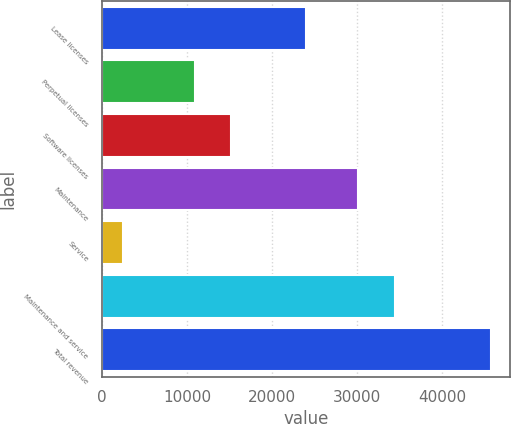<chart> <loc_0><loc_0><loc_500><loc_500><bar_chart><fcel>Lease licenses<fcel>Perpetual licenses<fcel>Software licenses<fcel>Maintenance<fcel>Service<fcel>Maintenance and service<fcel>Total revenue<nl><fcel>23964<fcel>10895<fcel>15217.3<fcel>30154<fcel>2489<fcel>34476.3<fcel>45712<nl></chart> 